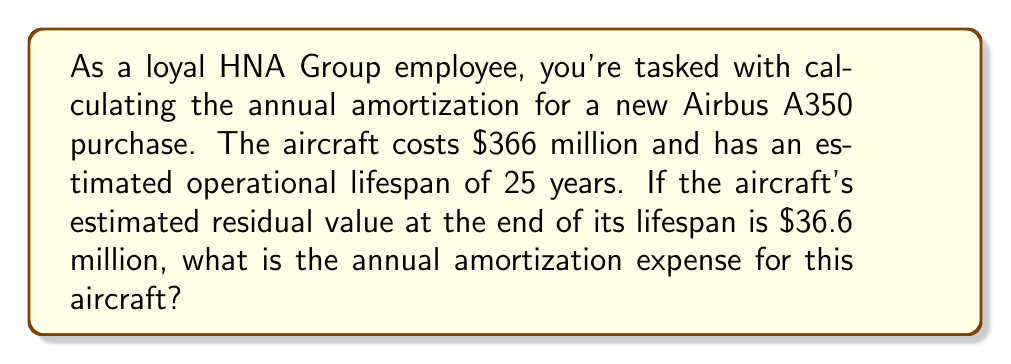What is the answer to this math problem? To calculate the annual amortization expense, we need to follow these steps:

1. Calculate the total amount to be amortized:
   Total amount = Purchase price - Residual value
   $$ \text{Total amount} = \$366,000,000 - \$36,600,000 = \$329,400,000 $$

2. Determine the amortization period:
   The operational lifespan of the aircraft is 25 years.

3. Calculate the annual amortization expense:
   Annual amortization = Total amount ÷ Amortization period
   $$ \text{Annual amortization} = \frac{\$329,400,000}{25 \text{ years}} = \$13,176,000 \text{ per year} $$

This method of amortization is known as the straight-line method, where the expense is spread evenly over the asset's useful life. It's commonly used in the aviation industry for long-term assets like aircraft.
Answer: The annual amortization expense for the Airbus A350 is $13,176,000 per year. 